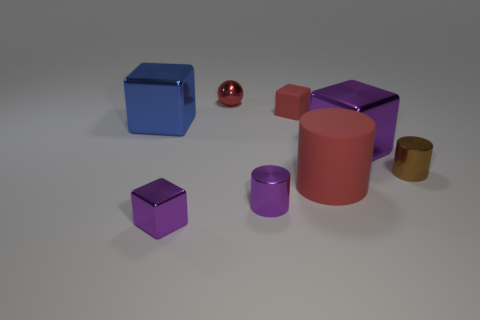What number of other things are the same shape as the tiny red metallic thing?
Provide a short and direct response. 0. The rubber cylinder that is the same size as the blue metal thing is what color?
Offer a terse response. Red. What is the color of the small metal thing on the left side of the shiny sphere?
Keep it short and to the point. Purple. Are there any tiny shiny cylinders that are right of the tiny metallic cylinder that is in front of the large red object?
Your answer should be very brief. Yes. Is the shape of the big red thing the same as the red matte object that is left of the big red thing?
Provide a succinct answer. No. There is a metallic thing that is in front of the red ball and behind the large purple metal object; what is its size?
Offer a terse response. Large. Are there any big things made of the same material as the red sphere?
Ensure brevity in your answer.  Yes. The cylinder that is the same color as the ball is what size?
Give a very brief answer. Large. There is a red thing in front of the tiny cube right of the red metal thing; what is it made of?
Your answer should be very brief. Rubber. What number of small objects are the same color as the tiny metal cube?
Make the answer very short. 1. 